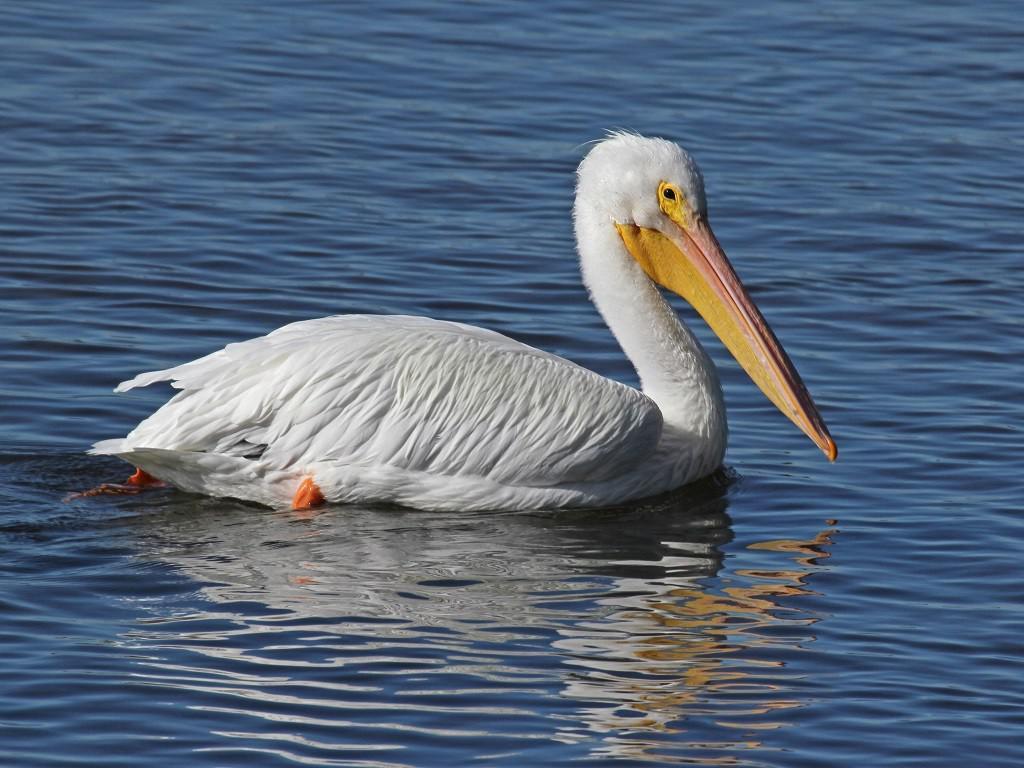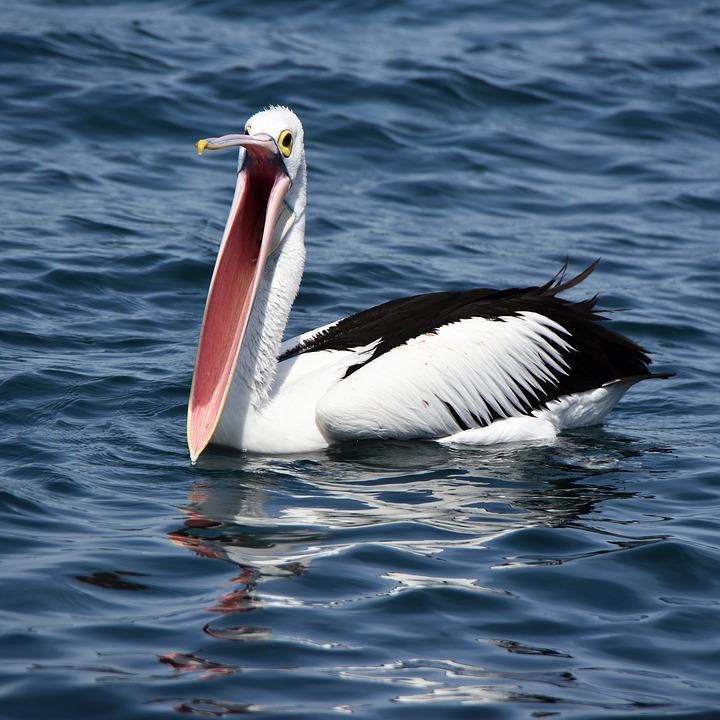The first image is the image on the left, the second image is the image on the right. For the images shown, is this caption "There are exactly two birds in one of the images." true? Answer yes or no. No. 